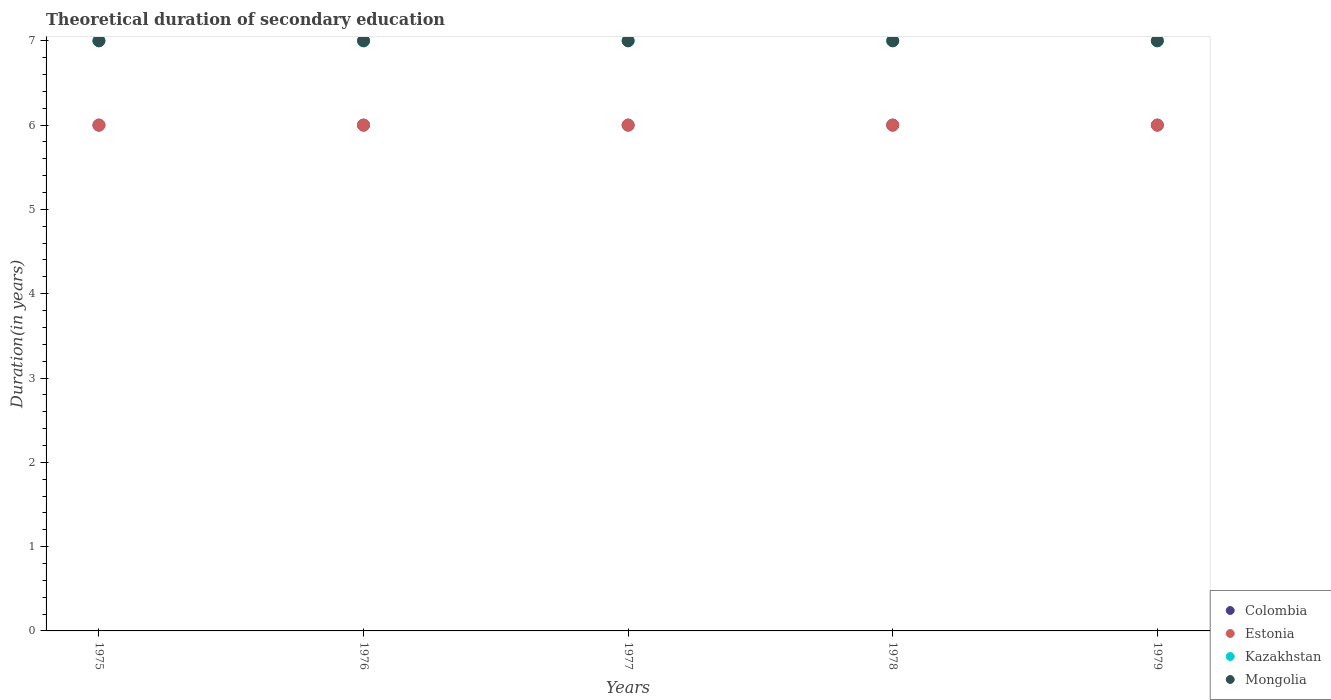What is the total theoretical duration of secondary education in Estonia in 1975?
Provide a succinct answer. 6. Across all years, what is the maximum total theoretical duration of secondary education in Mongolia?
Your answer should be very brief. 7. Across all years, what is the minimum total theoretical duration of secondary education in Mongolia?
Keep it short and to the point. 7. In which year was the total theoretical duration of secondary education in Estonia maximum?
Provide a succinct answer. 1975. In which year was the total theoretical duration of secondary education in Colombia minimum?
Your response must be concise. 1975. What is the total total theoretical duration of secondary education in Colombia in the graph?
Make the answer very short. 30. What is the difference between the total theoretical duration of secondary education in Colombia in 1979 and the total theoretical duration of secondary education in Kazakhstan in 1975?
Ensure brevity in your answer.  -1. What is the average total theoretical duration of secondary education in Mongolia per year?
Make the answer very short. 7. In the year 1977, what is the difference between the total theoretical duration of secondary education in Colombia and total theoretical duration of secondary education in Mongolia?
Provide a short and direct response. -1. In how many years, is the total theoretical duration of secondary education in Estonia greater than 3.6 years?
Keep it short and to the point. 5. What is the ratio of the total theoretical duration of secondary education in Estonia in 1975 to that in 1976?
Your response must be concise. 1. Is the difference between the total theoretical duration of secondary education in Colombia in 1975 and 1976 greater than the difference between the total theoretical duration of secondary education in Mongolia in 1975 and 1976?
Give a very brief answer. No. Is the sum of the total theoretical duration of secondary education in Estonia in 1976 and 1979 greater than the maximum total theoretical duration of secondary education in Kazakhstan across all years?
Provide a short and direct response. Yes. Is it the case that in every year, the sum of the total theoretical duration of secondary education in Colombia and total theoretical duration of secondary education in Kazakhstan  is greater than the sum of total theoretical duration of secondary education in Estonia and total theoretical duration of secondary education in Mongolia?
Your answer should be very brief. No. Does the total theoretical duration of secondary education in Mongolia monotonically increase over the years?
Keep it short and to the point. No. Is the total theoretical duration of secondary education in Colombia strictly less than the total theoretical duration of secondary education in Kazakhstan over the years?
Offer a very short reply. Yes. Does the graph contain any zero values?
Make the answer very short. No. Does the graph contain grids?
Your answer should be very brief. No. How many legend labels are there?
Ensure brevity in your answer.  4. What is the title of the graph?
Your answer should be compact. Theoretical duration of secondary education. What is the label or title of the X-axis?
Your answer should be compact. Years. What is the label or title of the Y-axis?
Your answer should be compact. Duration(in years). What is the Duration(in years) in Estonia in 1975?
Offer a terse response. 6. What is the Duration(in years) in Colombia in 1977?
Keep it short and to the point. 6. What is the Duration(in years) in Estonia in 1977?
Provide a succinct answer. 6. What is the Duration(in years) of Kazakhstan in 1977?
Your answer should be compact. 7. What is the Duration(in years) in Estonia in 1978?
Your response must be concise. 6. What is the Duration(in years) of Kazakhstan in 1978?
Provide a succinct answer. 7. What is the Duration(in years) in Colombia in 1979?
Your answer should be very brief. 6. Across all years, what is the maximum Duration(in years) in Colombia?
Keep it short and to the point. 6. Across all years, what is the maximum Duration(in years) in Kazakhstan?
Offer a very short reply. 7. Across all years, what is the maximum Duration(in years) of Mongolia?
Provide a succinct answer. 7. Across all years, what is the minimum Duration(in years) in Estonia?
Provide a short and direct response. 6. Across all years, what is the minimum Duration(in years) in Kazakhstan?
Offer a very short reply. 7. What is the total Duration(in years) of Colombia in the graph?
Make the answer very short. 30. What is the difference between the Duration(in years) in Colombia in 1975 and that in 1976?
Provide a short and direct response. 0. What is the difference between the Duration(in years) in Estonia in 1975 and that in 1976?
Your answer should be compact. 0. What is the difference between the Duration(in years) in Colombia in 1975 and that in 1977?
Your answer should be very brief. 0. What is the difference between the Duration(in years) in Estonia in 1975 and that in 1977?
Offer a very short reply. 0. What is the difference between the Duration(in years) in Kazakhstan in 1975 and that in 1977?
Your response must be concise. 0. What is the difference between the Duration(in years) in Kazakhstan in 1975 and that in 1978?
Give a very brief answer. 0. What is the difference between the Duration(in years) of Colombia in 1975 and that in 1979?
Your answer should be compact. 0. What is the difference between the Duration(in years) in Kazakhstan in 1975 and that in 1979?
Your answer should be very brief. 0. What is the difference between the Duration(in years) in Colombia in 1976 and that in 1977?
Ensure brevity in your answer.  0. What is the difference between the Duration(in years) in Estonia in 1976 and that in 1978?
Make the answer very short. 0. What is the difference between the Duration(in years) of Kazakhstan in 1976 and that in 1978?
Offer a very short reply. 0. What is the difference between the Duration(in years) of Estonia in 1977 and that in 1978?
Offer a terse response. 0. What is the difference between the Duration(in years) in Kazakhstan in 1977 and that in 1978?
Your answer should be compact. 0. What is the difference between the Duration(in years) of Mongolia in 1977 and that in 1979?
Your answer should be compact. 0. What is the difference between the Duration(in years) in Estonia in 1978 and that in 1979?
Offer a very short reply. 0. What is the difference between the Duration(in years) of Mongolia in 1978 and that in 1979?
Your answer should be compact. 0. What is the difference between the Duration(in years) in Colombia in 1975 and the Duration(in years) in Estonia in 1976?
Give a very brief answer. 0. What is the difference between the Duration(in years) in Colombia in 1975 and the Duration(in years) in Mongolia in 1976?
Your response must be concise. -1. What is the difference between the Duration(in years) of Estonia in 1975 and the Duration(in years) of Kazakhstan in 1976?
Provide a succinct answer. -1. What is the difference between the Duration(in years) in Estonia in 1975 and the Duration(in years) in Mongolia in 1976?
Make the answer very short. -1. What is the difference between the Duration(in years) in Kazakhstan in 1975 and the Duration(in years) in Mongolia in 1976?
Your answer should be very brief. 0. What is the difference between the Duration(in years) in Colombia in 1975 and the Duration(in years) in Kazakhstan in 1977?
Offer a very short reply. -1. What is the difference between the Duration(in years) in Estonia in 1975 and the Duration(in years) in Kazakhstan in 1977?
Provide a short and direct response. -1. What is the difference between the Duration(in years) of Kazakhstan in 1975 and the Duration(in years) of Mongolia in 1977?
Offer a terse response. 0. What is the difference between the Duration(in years) of Colombia in 1975 and the Duration(in years) of Estonia in 1978?
Your answer should be very brief. 0. What is the difference between the Duration(in years) of Colombia in 1975 and the Duration(in years) of Kazakhstan in 1978?
Your answer should be compact. -1. What is the difference between the Duration(in years) of Colombia in 1975 and the Duration(in years) of Mongolia in 1978?
Your answer should be very brief. -1. What is the difference between the Duration(in years) of Estonia in 1975 and the Duration(in years) of Kazakhstan in 1978?
Make the answer very short. -1. What is the difference between the Duration(in years) in Estonia in 1975 and the Duration(in years) in Mongolia in 1978?
Offer a very short reply. -1. What is the difference between the Duration(in years) in Colombia in 1975 and the Duration(in years) in Mongolia in 1979?
Your answer should be very brief. -1. What is the difference between the Duration(in years) in Estonia in 1975 and the Duration(in years) in Mongolia in 1979?
Keep it short and to the point. -1. What is the difference between the Duration(in years) of Kazakhstan in 1975 and the Duration(in years) of Mongolia in 1979?
Make the answer very short. 0. What is the difference between the Duration(in years) in Colombia in 1976 and the Duration(in years) in Estonia in 1977?
Offer a very short reply. 0. What is the difference between the Duration(in years) of Colombia in 1976 and the Duration(in years) of Kazakhstan in 1977?
Provide a short and direct response. -1. What is the difference between the Duration(in years) of Colombia in 1976 and the Duration(in years) of Mongolia in 1977?
Keep it short and to the point. -1. What is the difference between the Duration(in years) of Estonia in 1976 and the Duration(in years) of Kazakhstan in 1977?
Keep it short and to the point. -1. What is the difference between the Duration(in years) of Estonia in 1976 and the Duration(in years) of Mongolia in 1977?
Your answer should be compact. -1. What is the difference between the Duration(in years) in Kazakhstan in 1976 and the Duration(in years) in Mongolia in 1977?
Ensure brevity in your answer.  0. What is the difference between the Duration(in years) of Colombia in 1976 and the Duration(in years) of Estonia in 1978?
Your answer should be compact. 0. What is the difference between the Duration(in years) of Colombia in 1976 and the Duration(in years) of Kazakhstan in 1978?
Make the answer very short. -1. What is the difference between the Duration(in years) of Colombia in 1976 and the Duration(in years) of Mongolia in 1978?
Give a very brief answer. -1. What is the difference between the Duration(in years) in Colombia in 1976 and the Duration(in years) in Estonia in 1979?
Offer a terse response. 0. What is the difference between the Duration(in years) in Colombia in 1976 and the Duration(in years) in Mongolia in 1979?
Give a very brief answer. -1. What is the difference between the Duration(in years) of Estonia in 1976 and the Duration(in years) of Kazakhstan in 1979?
Offer a terse response. -1. What is the difference between the Duration(in years) of Colombia in 1977 and the Duration(in years) of Kazakhstan in 1978?
Provide a short and direct response. -1. What is the difference between the Duration(in years) in Colombia in 1977 and the Duration(in years) in Mongolia in 1978?
Your answer should be very brief. -1. What is the difference between the Duration(in years) of Estonia in 1977 and the Duration(in years) of Kazakhstan in 1978?
Your response must be concise. -1. What is the difference between the Duration(in years) in Estonia in 1977 and the Duration(in years) in Mongolia in 1978?
Give a very brief answer. -1. What is the difference between the Duration(in years) of Colombia in 1977 and the Duration(in years) of Estonia in 1979?
Ensure brevity in your answer.  0. What is the difference between the Duration(in years) of Colombia in 1977 and the Duration(in years) of Mongolia in 1979?
Your answer should be very brief. -1. What is the difference between the Duration(in years) in Estonia in 1977 and the Duration(in years) in Mongolia in 1979?
Give a very brief answer. -1. What is the difference between the Duration(in years) of Estonia in 1978 and the Duration(in years) of Kazakhstan in 1979?
Keep it short and to the point. -1. What is the difference between the Duration(in years) in Estonia in 1978 and the Duration(in years) in Mongolia in 1979?
Make the answer very short. -1. In the year 1975, what is the difference between the Duration(in years) in Colombia and Duration(in years) in Estonia?
Your answer should be very brief. 0. In the year 1975, what is the difference between the Duration(in years) in Colombia and Duration(in years) in Kazakhstan?
Offer a very short reply. -1. In the year 1975, what is the difference between the Duration(in years) in Estonia and Duration(in years) in Mongolia?
Provide a succinct answer. -1. In the year 1975, what is the difference between the Duration(in years) in Kazakhstan and Duration(in years) in Mongolia?
Give a very brief answer. 0. In the year 1976, what is the difference between the Duration(in years) of Colombia and Duration(in years) of Estonia?
Your answer should be compact. 0. In the year 1976, what is the difference between the Duration(in years) in Colombia and Duration(in years) in Kazakhstan?
Give a very brief answer. -1. In the year 1976, what is the difference between the Duration(in years) of Estonia and Duration(in years) of Kazakhstan?
Make the answer very short. -1. In the year 1977, what is the difference between the Duration(in years) of Colombia and Duration(in years) of Estonia?
Your response must be concise. 0. In the year 1977, what is the difference between the Duration(in years) of Colombia and Duration(in years) of Kazakhstan?
Your answer should be compact. -1. In the year 1977, what is the difference between the Duration(in years) in Estonia and Duration(in years) in Mongolia?
Offer a terse response. -1. In the year 1977, what is the difference between the Duration(in years) of Kazakhstan and Duration(in years) of Mongolia?
Offer a very short reply. 0. In the year 1978, what is the difference between the Duration(in years) in Colombia and Duration(in years) in Estonia?
Offer a very short reply. 0. In the year 1978, what is the difference between the Duration(in years) of Colombia and Duration(in years) of Kazakhstan?
Provide a succinct answer. -1. In the year 1978, what is the difference between the Duration(in years) in Colombia and Duration(in years) in Mongolia?
Ensure brevity in your answer.  -1. In the year 1978, what is the difference between the Duration(in years) of Estonia and Duration(in years) of Mongolia?
Provide a succinct answer. -1. In the year 1978, what is the difference between the Duration(in years) in Kazakhstan and Duration(in years) in Mongolia?
Give a very brief answer. 0. In the year 1979, what is the difference between the Duration(in years) in Colombia and Duration(in years) in Kazakhstan?
Give a very brief answer. -1. In the year 1979, what is the difference between the Duration(in years) of Colombia and Duration(in years) of Mongolia?
Give a very brief answer. -1. In the year 1979, what is the difference between the Duration(in years) in Estonia and Duration(in years) in Kazakhstan?
Make the answer very short. -1. In the year 1979, what is the difference between the Duration(in years) of Kazakhstan and Duration(in years) of Mongolia?
Provide a short and direct response. 0. What is the ratio of the Duration(in years) in Estonia in 1975 to that in 1976?
Ensure brevity in your answer.  1. What is the ratio of the Duration(in years) of Mongolia in 1975 to that in 1976?
Offer a terse response. 1. What is the ratio of the Duration(in years) in Estonia in 1975 to that in 1977?
Make the answer very short. 1. What is the ratio of the Duration(in years) of Kazakhstan in 1975 to that in 1978?
Your answer should be compact. 1. What is the ratio of the Duration(in years) in Estonia in 1975 to that in 1979?
Keep it short and to the point. 1. What is the ratio of the Duration(in years) of Mongolia in 1975 to that in 1979?
Keep it short and to the point. 1. What is the ratio of the Duration(in years) of Estonia in 1976 to that in 1977?
Make the answer very short. 1. What is the ratio of the Duration(in years) of Colombia in 1976 to that in 1978?
Your answer should be compact. 1. What is the ratio of the Duration(in years) of Estonia in 1976 to that in 1978?
Make the answer very short. 1. What is the ratio of the Duration(in years) of Kazakhstan in 1976 to that in 1978?
Make the answer very short. 1. What is the ratio of the Duration(in years) of Colombia in 1976 to that in 1979?
Keep it short and to the point. 1. What is the ratio of the Duration(in years) in Mongolia in 1976 to that in 1979?
Offer a very short reply. 1. What is the ratio of the Duration(in years) in Estonia in 1977 to that in 1978?
Provide a short and direct response. 1. What is the ratio of the Duration(in years) of Kazakhstan in 1977 to that in 1978?
Provide a succinct answer. 1. What is the ratio of the Duration(in years) of Mongolia in 1977 to that in 1978?
Keep it short and to the point. 1. What is the ratio of the Duration(in years) in Colombia in 1977 to that in 1979?
Make the answer very short. 1. What is the ratio of the Duration(in years) of Kazakhstan in 1977 to that in 1979?
Provide a short and direct response. 1. What is the ratio of the Duration(in years) in Mongolia in 1977 to that in 1979?
Provide a short and direct response. 1. What is the ratio of the Duration(in years) of Colombia in 1978 to that in 1979?
Make the answer very short. 1. What is the difference between the highest and the second highest Duration(in years) in Colombia?
Give a very brief answer. 0. What is the difference between the highest and the second highest Duration(in years) in Estonia?
Offer a very short reply. 0. What is the difference between the highest and the second highest Duration(in years) in Mongolia?
Your answer should be very brief. 0. What is the difference between the highest and the lowest Duration(in years) in Colombia?
Your answer should be very brief. 0. What is the difference between the highest and the lowest Duration(in years) of Kazakhstan?
Offer a terse response. 0. What is the difference between the highest and the lowest Duration(in years) of Mongolia?
Your answer should be compact. 0. 